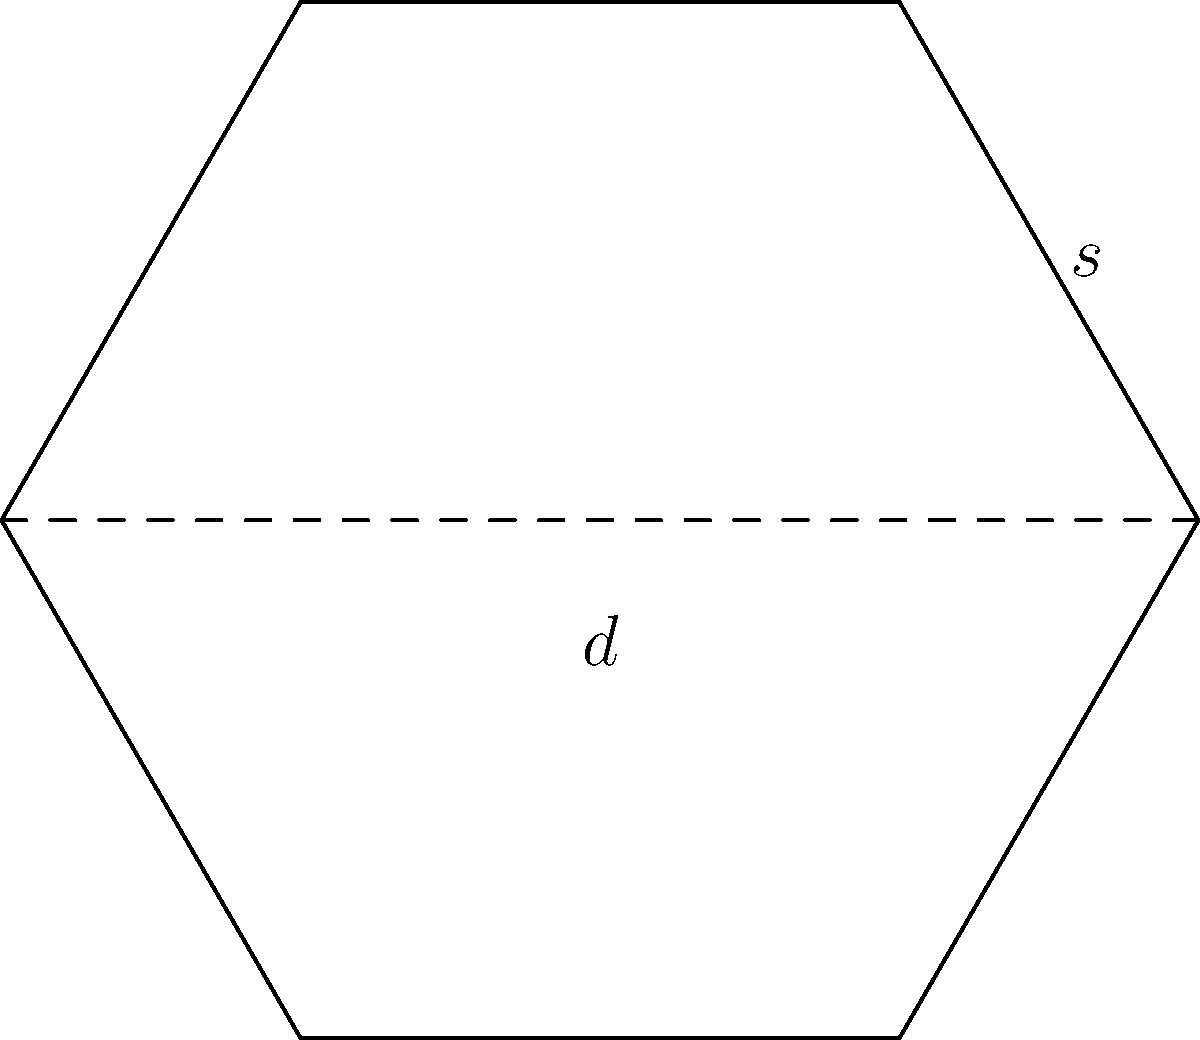The United Nations is proposing a new hexagonal diplomatic meeting room. If the side length of the hexagon is $s$ meters, what is the cross-sectional area of the room in terms of $s$? To find the area of a regular hexagon, we can follow these steps:

1) First, we need to recognize that a regular hexagon can be divided into six equilateral triangles.

2) The area of the hexagon will be six times the area of one of these triangles.

3) For an equilateral triangle with side length $s$, the height $h$ is:

   $$h = s\frac{\sqrt{3}}{2}$$

4) The area of this triangle is:

   $$A_{triangle} = \frac{1}{2} \cdot s \cdot h = \frac{1}{2} \cdot s \cdot s\frac{\sqrt{3}}{2} = \frac{\sqrt{3}}{4}s^2$$

5) The area of the hexagon is six times this:

   $$A_{hexagon} = 6 \cdot \frac{\sqrt{3}}{4}s^2 = \frac{3\sqrt{3}}{2}s^2$$

Therefore, the cross-sectional area of the hexagonal room is $\frac{3\sqrt{3}}{2}s^2$ square meters.
Answer: $\frac{3\sqrt{3}}{2}s^2$ square meters 